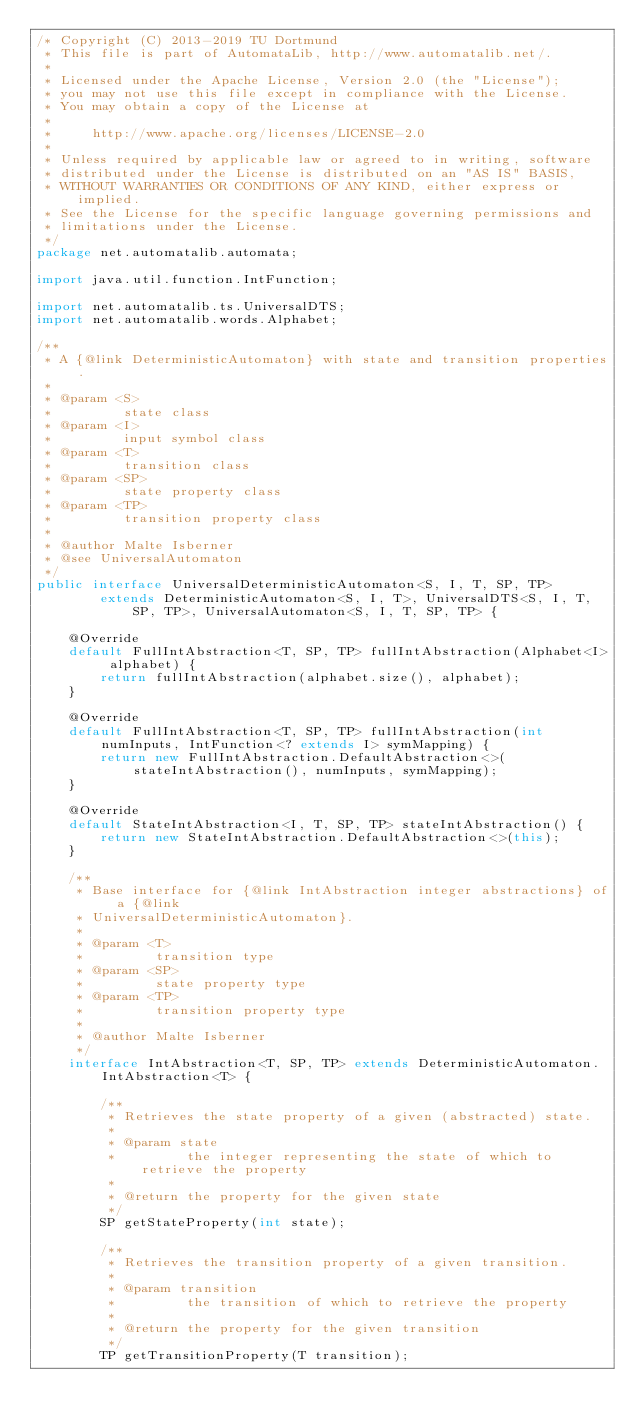<code> <loc_0><loc_0><loc_500><loc_500><_Java_>/* Copyright (C) 2013-2019 TU Dortmund
 * This file is part of AutomataLib, http://www.automatalib.net/.
 *
 * Licensed under the Apache License, Version 2.0 (the "License");
 * you may not use this file except in compliance with the License.
 * You may obtain a copy of the License at
 *
 *     http://www.apache.org/licenses/LICENSE-2.0
 *
 * Unless required by applicable law or agreed to in writing, software
 * distributed under the License is distributed on an "AS IS" BASIS,
 * WITHOUT WARRANTIES OR CONDITIONS OF ANY KIND, either express or implied.
 * See the License for the specific language governing permissions and
 * limitations under the License.
 */
package net.automatalib.automata;

import java.util.function.IntFunction;

import net.automatalib.ts.UniversalDTS;
import net.automatalib.words.Alphabet;

/**
 * A {@link DeterministicAutomaton} with state and transition properties.
 *
 * @param <S>
 *         state class
 * @param <I>
 *         input symbol class
 * @param <T>
 *         transition class
 * @param <SP>
 *         state property class
 * @param <TP>
 *         transition property class
 *
 * @author Malte Isberner
 * @see UniversalAutomaton
 */
public interface UniversalDeterministicAutomaton<S, I, T, SP, TP>
        extends DeterministicAutomaton<S, I, T>, UniversalDTS<S, I, T, SP, TP>, UniversalAutomaton<S, I, T, SP, TP> {

    @Override
    default FullIntAbstraction<T, SP, TP> fullIntAbstraction(Alphabet<I> alphabet) {
        return fullIntAbstraction(alphabet.size(), alphabet);
    }

    @Override
    default FullIntAbstraction<T, SP, TP> fullIntAbstraction(int numInputs, IntFunction<? extends I> symMapping) {
        return new FullIntAbstraction.DefaultAbstraction<>(stateIntAbstraction(), numInputs, symMapping);
    }

    @Override
    default StateIntAbstraction<I, T, SP, TP> stateIntAbstraction() {
        return new StateIntAbstraction.DefaultAbstraction<>(this);
    }

    /**
     * Base interface for {@link IntAbstraction integer abstractions} of a {@link
     * UniversalDeterministicAutomaton}.
     *
     * @param <T>
     *         transition type
     * @param <SP>
     *         state property type
     * @param <TP>
     *         transition property type
     *
     * @author Malte Isberner
     */
    interface IntAbstraction<T, SP, TP> extends DeterministicAutomaton.IntAbstraction<T> {

        /**
         * Retrieves the state property of a given (abstracted) state.
         *
         * @param state
         *         the integer representing the state of which to retrieve the property
         *
         * @return the property for the given state
         */
        SP getStateProperty(int state);

        /**
         * Retrieves the transition property of a given transition.
         *
         * @param transition
         *         the transition of which to retrieve the property
         *
         * @return the property for the given transition
         */
        TP getTransitionProperty(T transition);</code> 